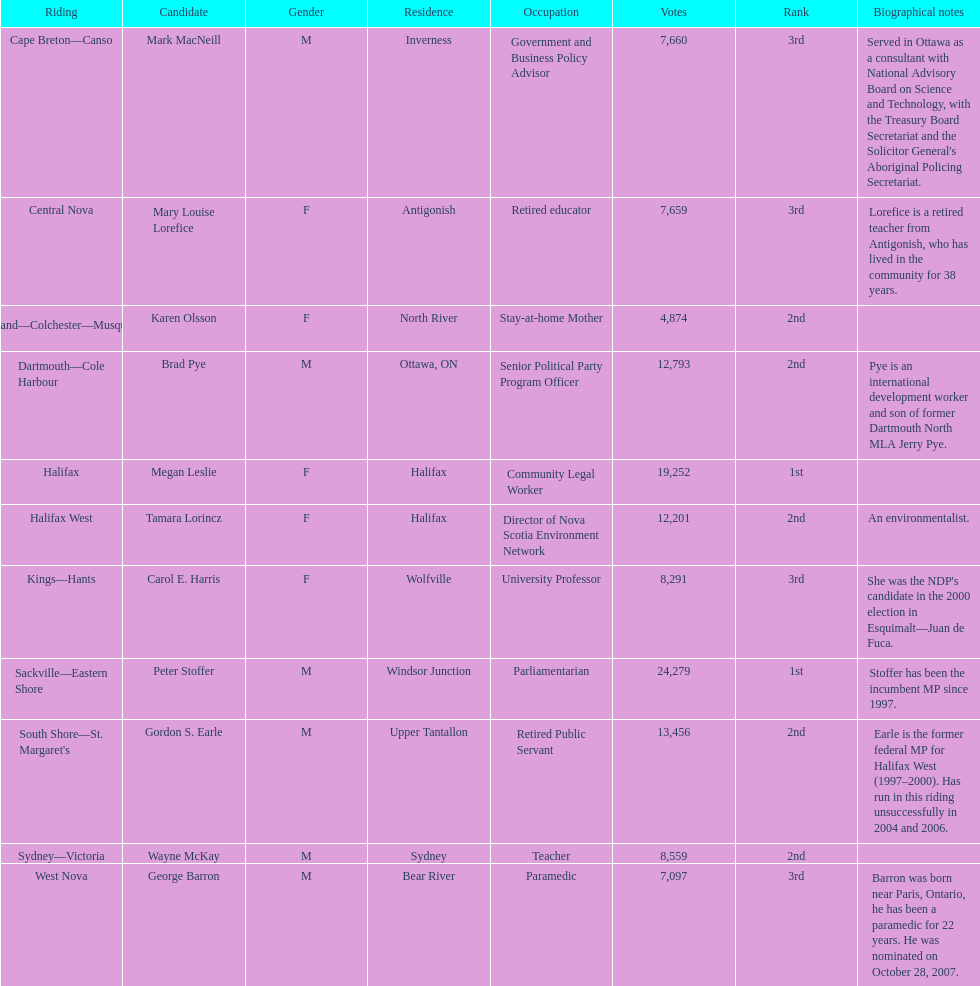Who got a larger number of votes, macneill or olsson? Mark MacNeill. 